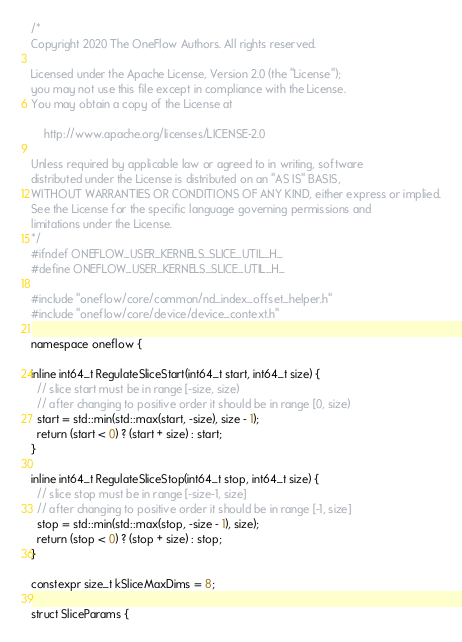<code> <loc_0><loc_0><loc_500><loc_500><_C_>/*
Copyright 2020 The OneFlow Authors. All rights reserved.

Licensed under the Apache License, Version 2.0 (the "License");
you may not use this file except in compliance with the License.
You may obtain a copy of the License at

    http://www.apache.org/licenses/LICENSE-2.0

Unless required by applicable law or agreed to in writing, software
distributed under the License is distributed on an "AS IS" BASIS,
WITHOUT WARRANTIES OR CONDITIONS OF ANY KIND, either express or implied.
See the License for the specific language governing permissions and
limitations under the License.
*/
#ifndef ONEFLOW_USER_KERNELS_SLICE_UTIL_H_
#define ONEFLOW_USER_KERNELS_SLICE_UTIL_H_

#include "oneflow/core/common/nd_index_offset_helper.h"
#include "oneflow/core/device/device_context.h"

namespace oneflow {

inline int64_t RegulateSliceStart(int64_t start, int64_t size) {
  // slice start must be in range [-size, size)
  // after changing to positive order it should be in range [0, size)
  start = std::min(std::max(start, -size), size - 1);
  return (start < 0) ? (start + size) : start;
}

inline int64_t RegulateSliceStop(int64_t stop, int64_t size) {
  // slice stop must be in range [-size-1, size]
  // after changing to positive order it should be in range [-1, size]
  stop = std::min(std::max(stop, -size - 1), size);
  return (stop < 0) ? (stop + size) : stop;
}

constexpr size_t kSliceMaxDims = 8;

struct SliceParams {</code> 